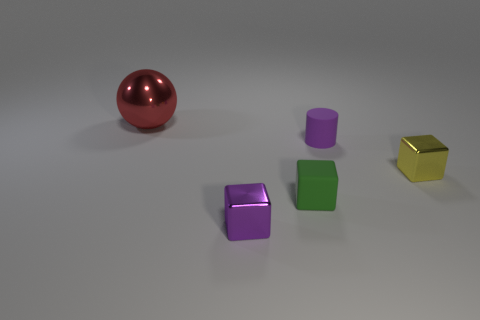Add 1 small metal blocks. How many objects exist? 6 Subtract all cylinders. How many objects are left? 4 Add 5 tiny shiny cubes. How many tiny shiny cubes exist? 7 Subtract 1 yellow blocks. How many objects are left? 4 Subtract all tiny shiny cylinders. Subtract all shiny spheres. How many objects are left? 4 Add 4 small purple shiny cubes. How many small purple shiny cubes are left? 5 